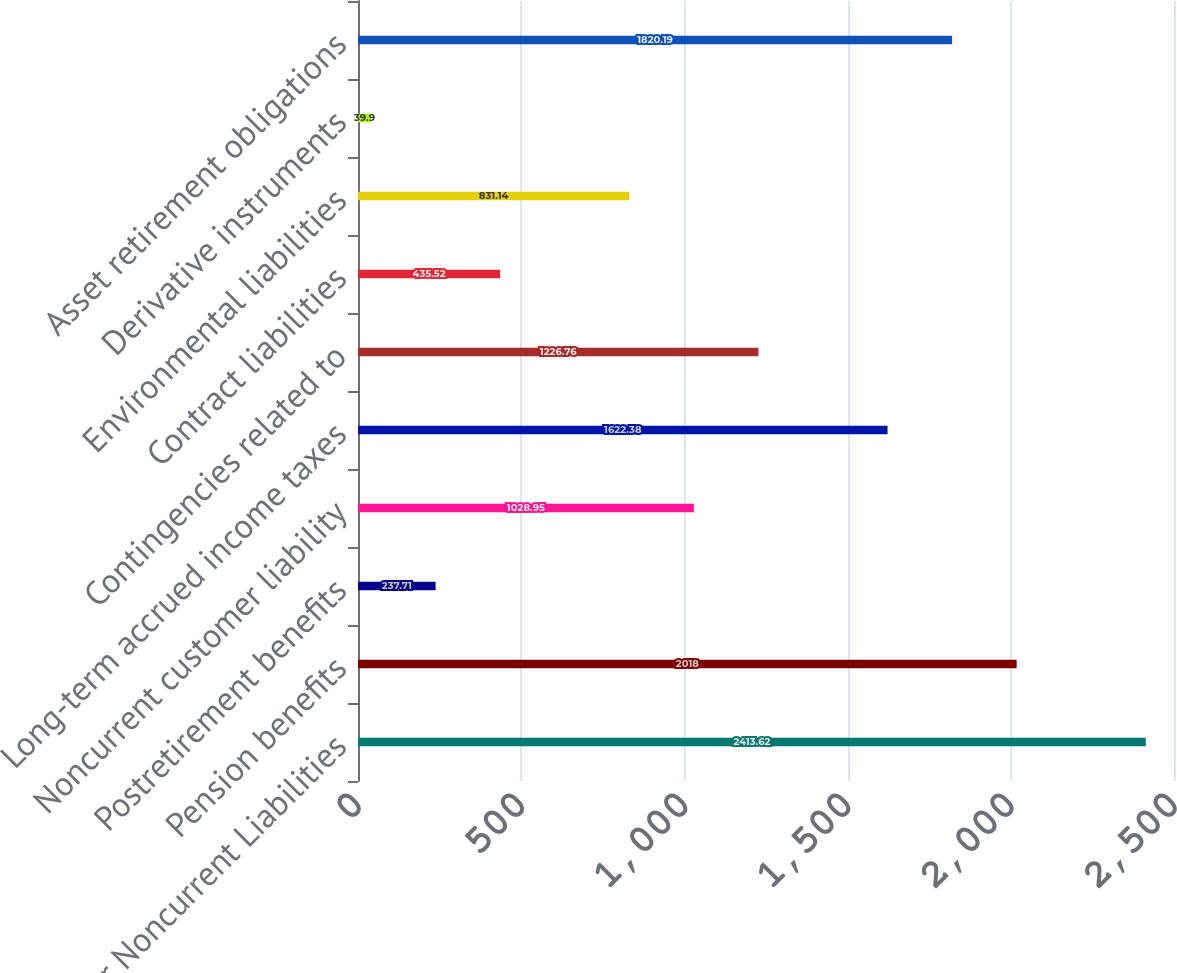Convert chart to OTSL. <chart><loc_0><loc_0><loc_500><loc_500><bar_chart><fcel>Other Noncurrent Liabilities<fcel>Pension benefits<fcel>Postretirement benefits<fcel>Noncurrent customer liability<fcel>Long-term accrued income taxes<fcel>Contingencies related to<fcel>Contract liabilities<fcel>Environmental liabilities<fcel>Derivative instruments<fcel>Asset retirement obligations<nl><fcel>2413.62<fcel>2018<fcel>237.71<fcel>1028.95<fcel>1622.38<fcel>1226.76<fcel>435.52<fcel>831.14<fcel>39.9<fcel>1820.19<nl></chart> 